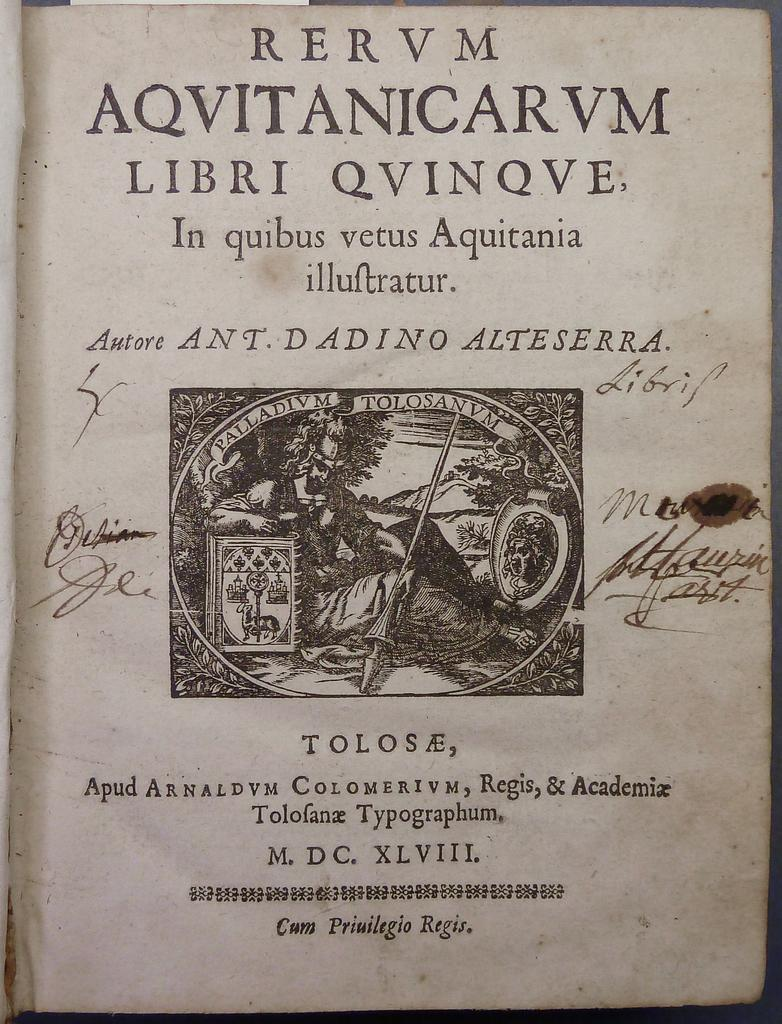<image>
Share a concise interpretation of the image provided. A page from an ancient book showing RERUM written in Latin on the very top. 